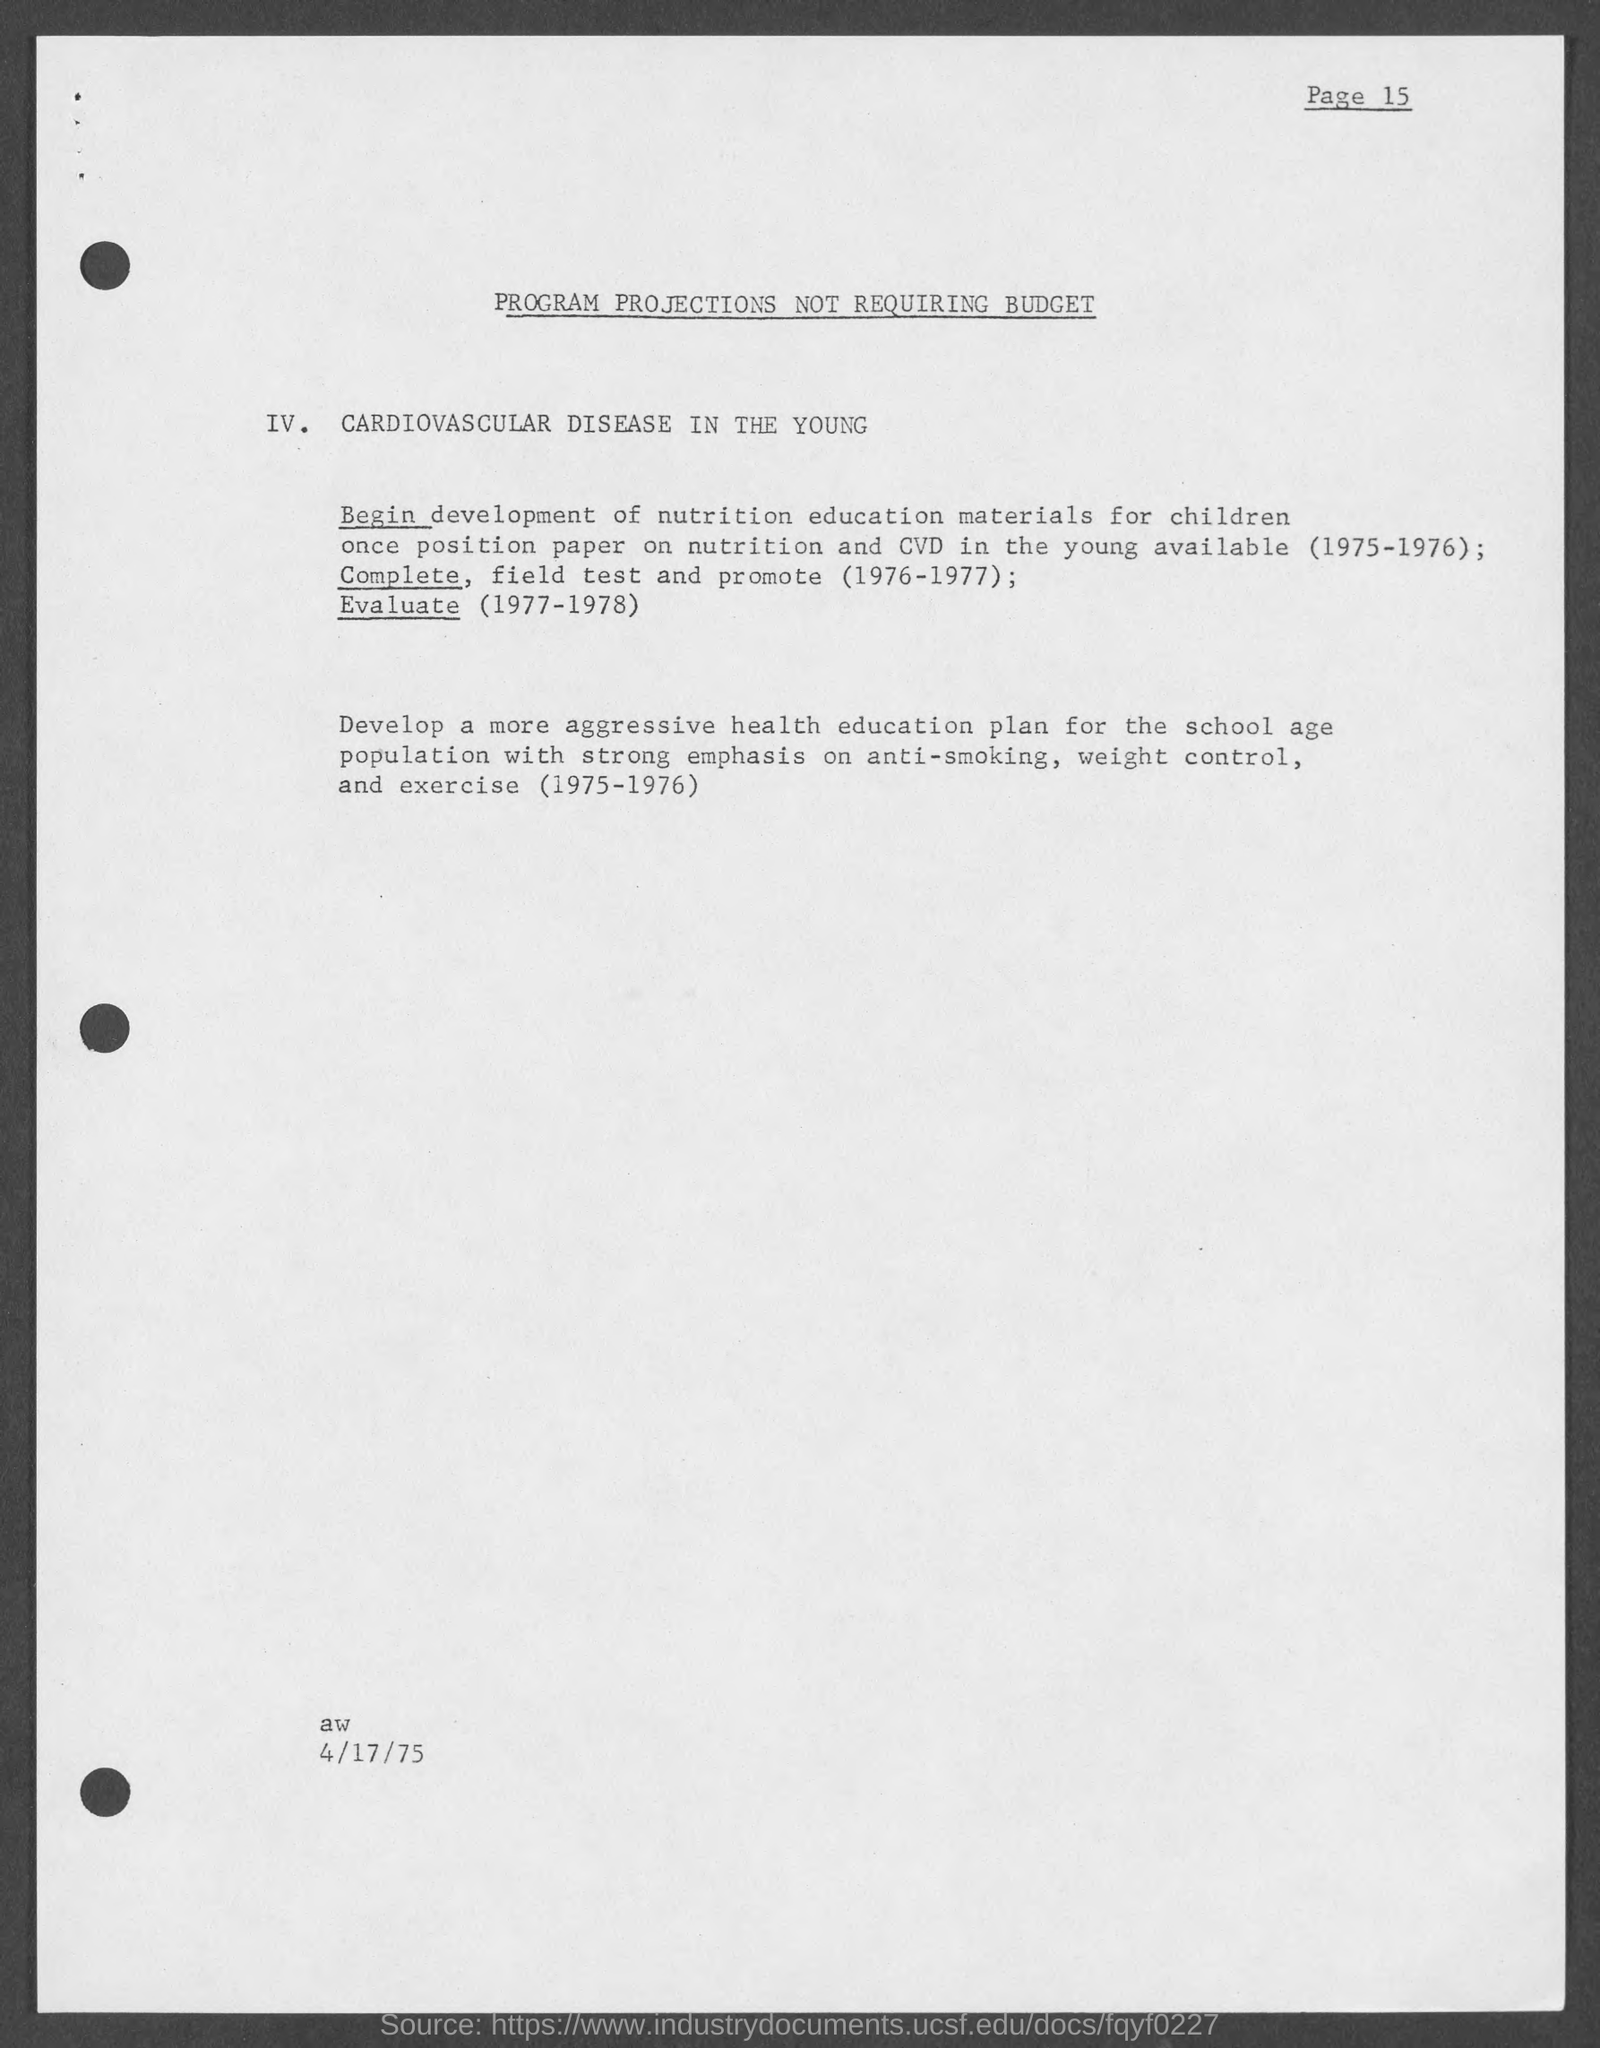In which Page Number is mentioned?
Offer a very short reply. Page 15. What type of instruction is given to school age children in this program?
Provide a succinct answer. Anti-smoking, weight control and exercise. 